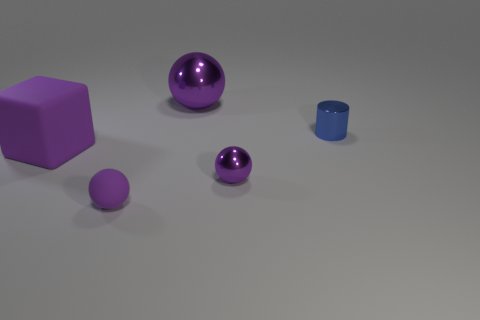What material is the big purple block?
Make the answer very short. Rubber. Are any small green metallic spheres visible?
Provide a succinct answer. No. Is the number of tiny shiny objects in front of the tiny rubber object the same as the number of red metal objects?
Give a very brief answer. Yes. Are there any other things that are made of the same material as the blue cylinder?
Your response must be concise. Yes. How many small objects are matte things or purple spheres?
Your answer should be compact. 2. What is the shape of the other metal thing that is the same color as the big metallic object?
Offer a very short reply. Sphere. Are the purple ball to the right of the big purple metallic ball and the big purple block made of the same material?
Provide a short and direct response. No. The tiny object behind the small metallic object that is to the left of the tiny metallic cylinder is made of what material?
Keep it short and to the point. Metal. How many small rubber objects are the same shape as the small purple metal object?
Your response must be concise. 1. What is the size of the purple thing that is in front of the small purple metal object that is in front of the large object right of the large cube?
Your answer should be compact. Small. 